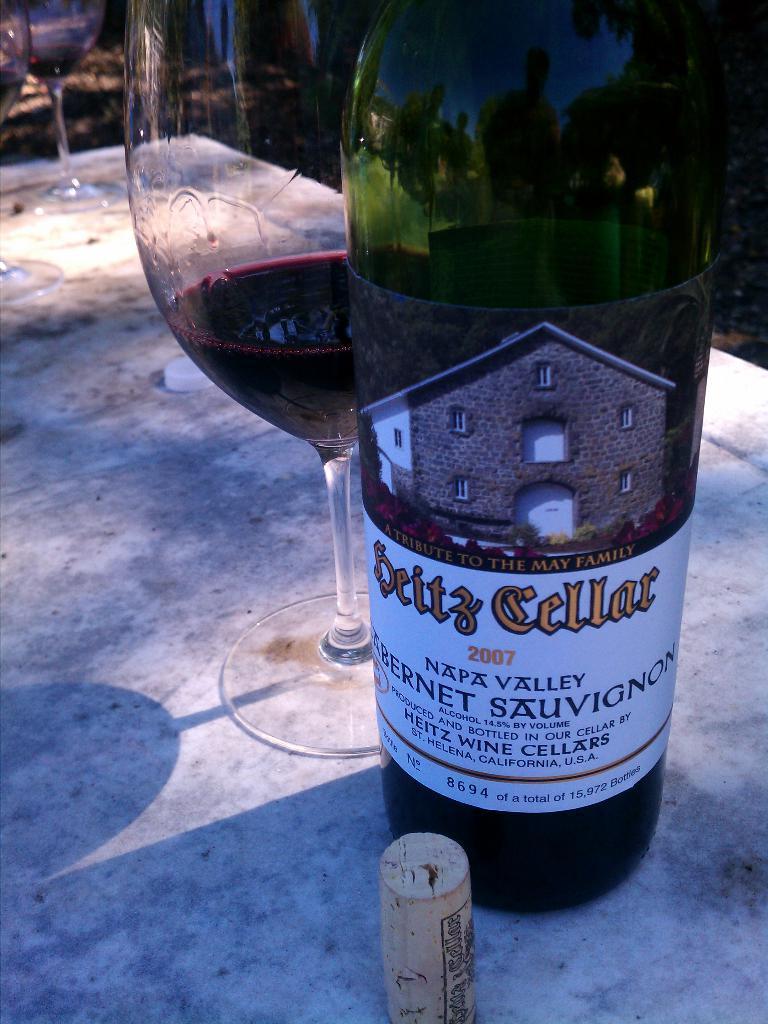In one or two sentences, can you explain what this image depicts? On the table there are three glasses and one bottle with a label on it. 